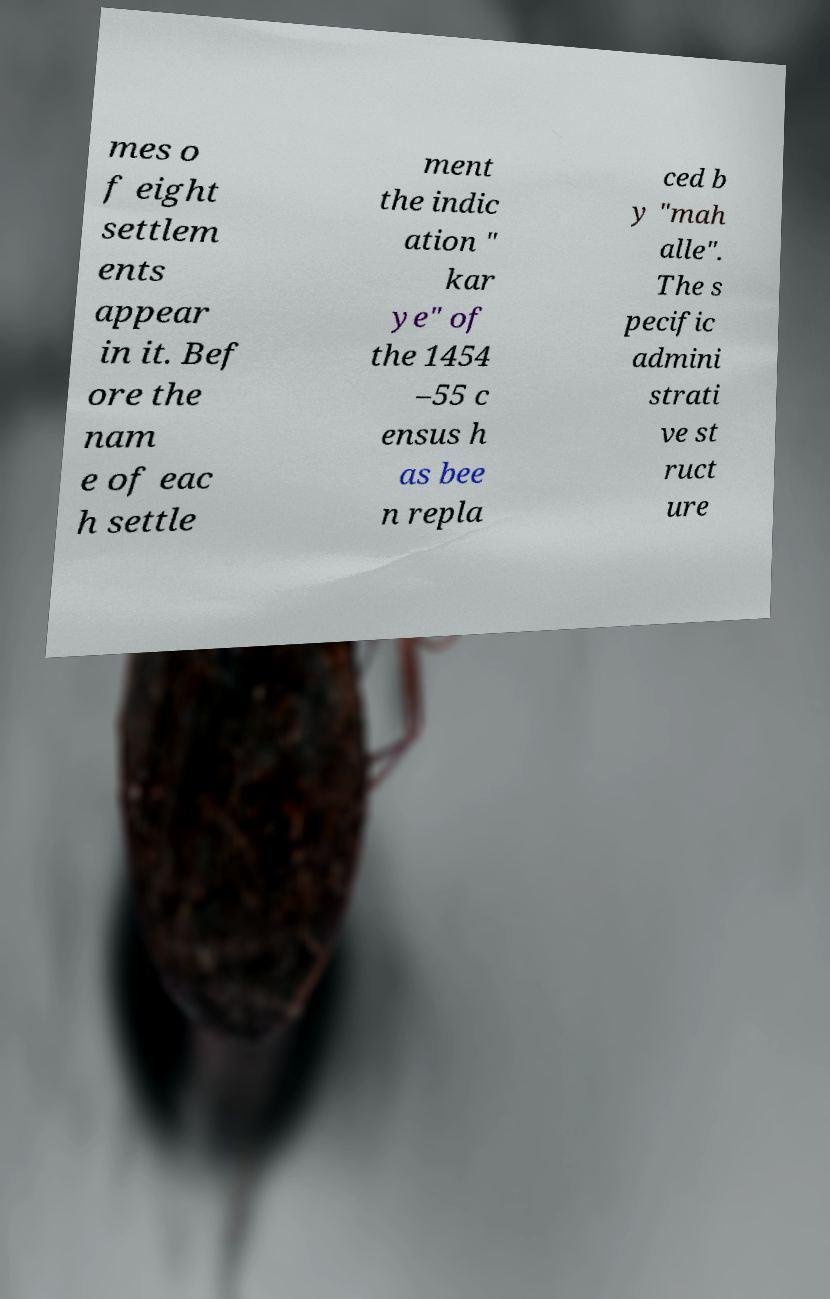For documentation purposes, I need the text within this image transcribed. Could you provide that? mes o f eight settlem ents appear in it. Bef ore the nam e of eac h settle ment the indic ation " kar ye" of the 1454 –55 c ensus h as bee n repla ced b y "mah alle". The s pecific admini strati ve st ruct ure 